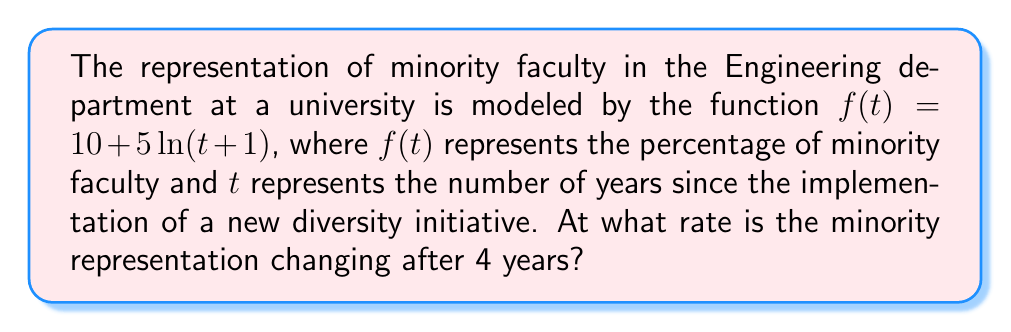Can you solve this math problem? To find the rate of change of minority representation after 4 years, we need to calculate the derivative of the given function and evaluate it at $t=4$.

1. Given function: $f(t) = 10 + 5\ln(t+1)$

2. Calculate the derivative:
   $$\frac{d}{dt}f(t) = \frac{d}{dt}[10 + 5\ln(t+1)]$$
   $$f'(t) = 0 + 5 \cdot \frac{1}{t+1}$$
   $$f'(t) = \frac{5}{t+1}$$

3. Evaluate the derivative at $t=4$:
   $$f'(4) = \frac{5}{4+1} = \frac{5}{5} = 1$$

The rate of change is 1 percentage point per year after 4 years.

4. Interpretation:
   This result indicates that the minority representation in the Engineering department is increasing at a rate of 1 percentage point per year, 4 years after the implementation of the diversity initiative.
Answer: 1 percentage point per year 